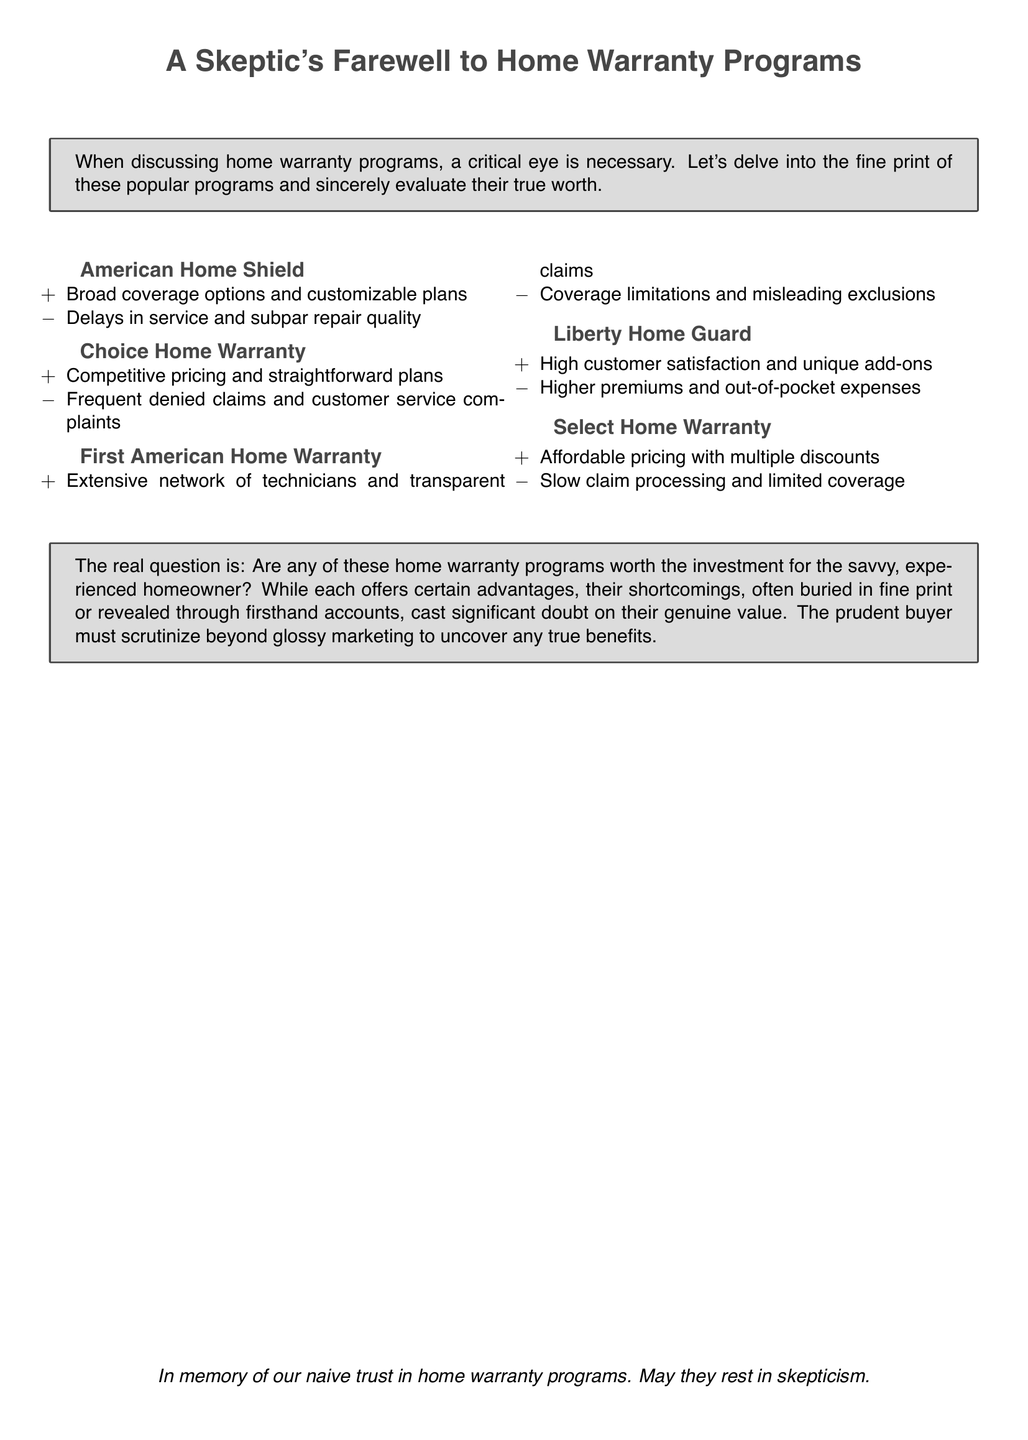What is the title of the document? The title of the document is presented prominently at the beginning and indicates the overall theme and perspective the text will take.
Answer: A Skeptic's Farewell to Home Warranty Programs How many home warranty programs are discussed? The document discusses five different home warranty programs, which are listed in the text.
Answer: Five What is a noted pro of American Home Shield? The document mentions a specific advantage associated with American Home Shield that is clearly outlined under its description.
Answer: Broad coverage options and customizable plans What is a common con among the programs mentioned? The document highlights several downsides associated with these home warranty programs, reflecting concerns that might arise among users.
Answer: Frequent denied claims Which program is described as having high customer satisfaction? The text provides specific positive feedback regarding one of the programs, indicating its perceived customer service success.
Answer: Liberty Home Guard What is the final sentiment expressed towards home warranty programs? The document concludes with a reflective statement that encapsulates the author’s feelings toward home warranty programs.
Answer: May they rest in skepticism What type of buyer is the document ultimately addressing? The language throughout the document suggests a target audience that would be looking critically at home warranty options.
Answer: Savvy, experienced homeowner What does the document suggest as necessary when reviewing home warranty programs? The text urges readers to engage in a particular approach when considering these services.
Answer: Scrutinize beyond glossy marketing 